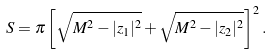<formula> <loc_0><loc_0><loc_500><loc_500>S = \pi \left [ \sqrt { M ^ { 2 } - | z _ { 1 } | ^ { 2 } } + \sqrt { M ^ { 2 } - | z _ { 2 } | ^ { 2 } } \right ] ^ { 2 } .</formula> 